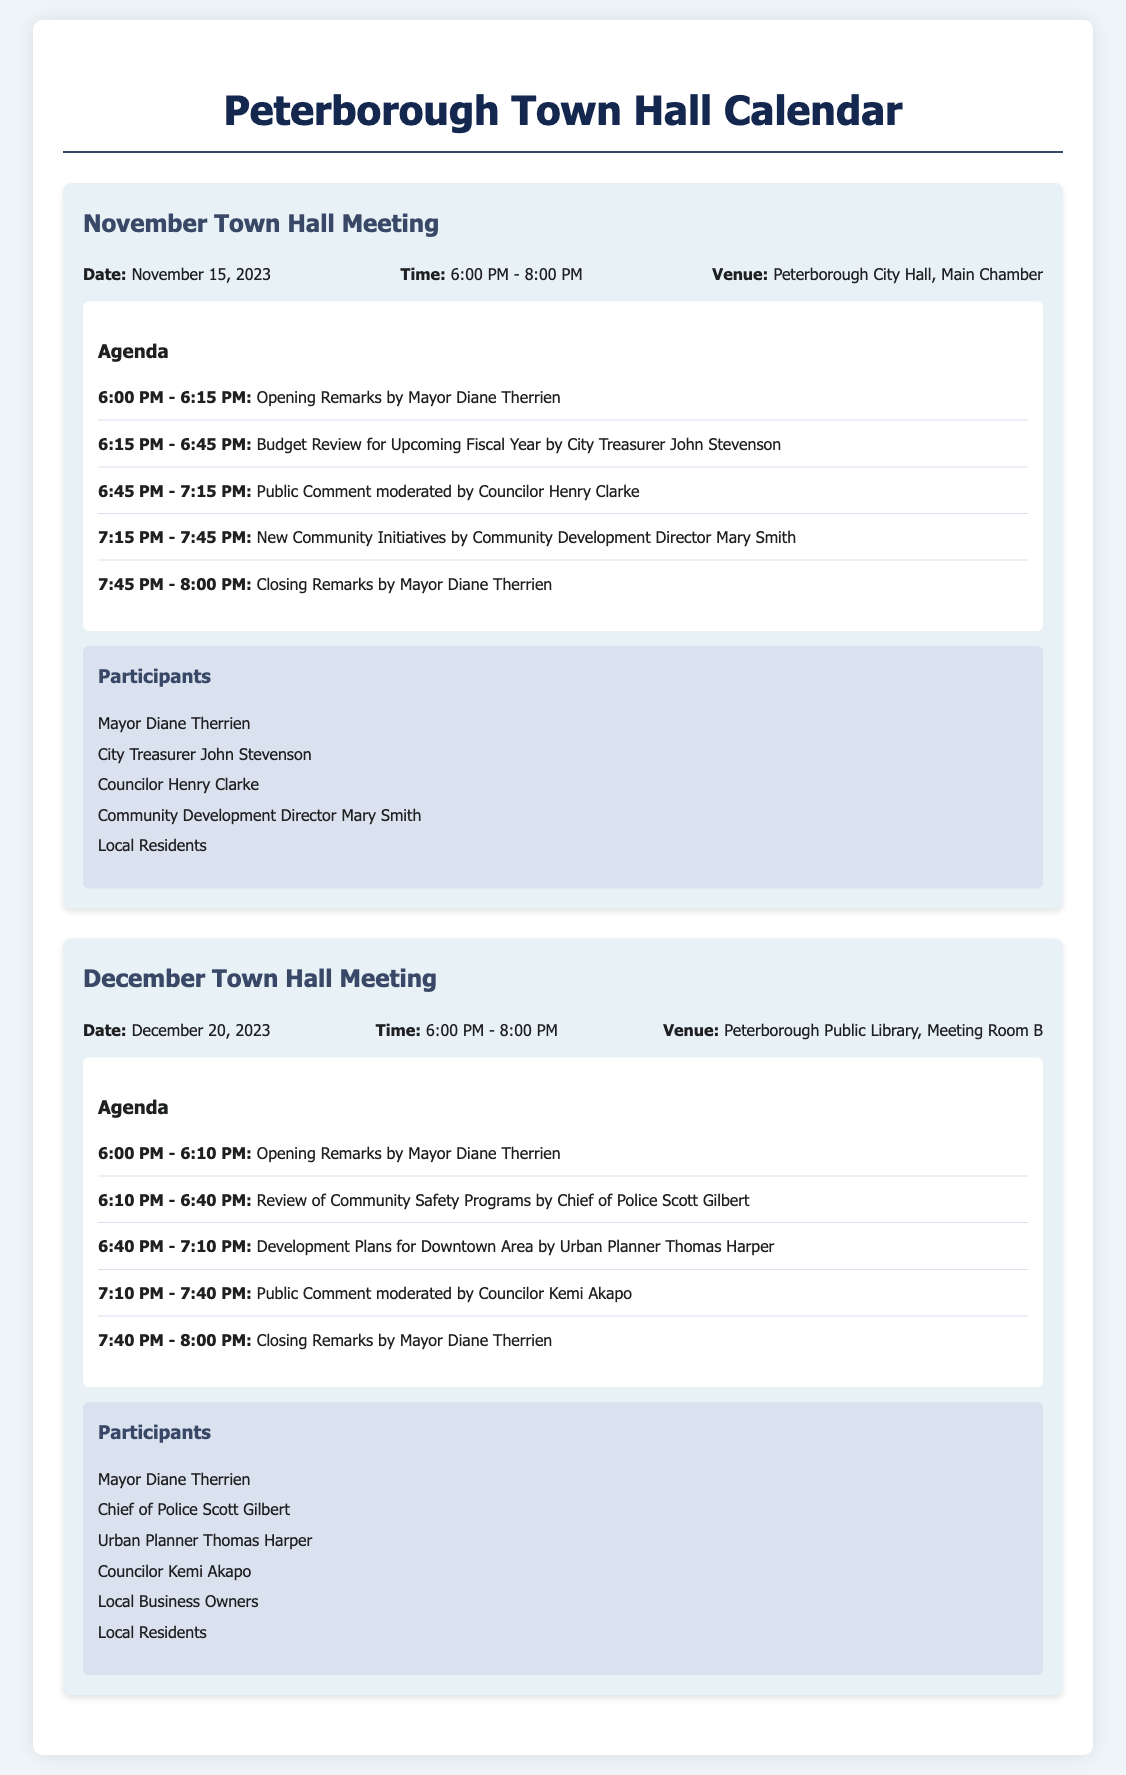What is the date of the November Town Hall Meeting? The date of the November Town Hall Meeting is explicitly listed in the document.
Answer: November 15, 2023 Who is presenting the Budget Review? The document lists the agenda item along with the individual's name presenting the review.
Answer: City Treasurer John Stevenson What time does the December Town Hall Meeting start? The starting time of the meeting is stated in the meeting information section of the document.
Answer: 6:00 PM How long is the public comment period in the November meeting? The agenda specifies the time allocated for public comment during the meeting.
Answer: 30 minutes Which venue will host the December Town Hall Meeting? The venue for the December meeting is clearly mentioned in the meeting information.
Answer: Peterborough Public Library, Meeting Room B Who will give the opening remarks for the November meeting? The individual responsible for opening remarks is listed at the beginning of the agenda for the November meeting.
Answer: Mayor Diane Therrien What is the last agenda item for the December meeting? The last agenda item is presented at the end of the agenda section in the document.
Answer: Closing Remarks by Mayor Diane Therrien How many participants are listed for the December Town Hall Meeting? The number of participants is derived from the participants list in the document for the December meeting.
Answer: 6 participants Who is moderating the public comment during the December meeting? The moderator for the public comment segment is identified within the agenda for the December meeting.
Answer: Councilor Kemi Akapo 